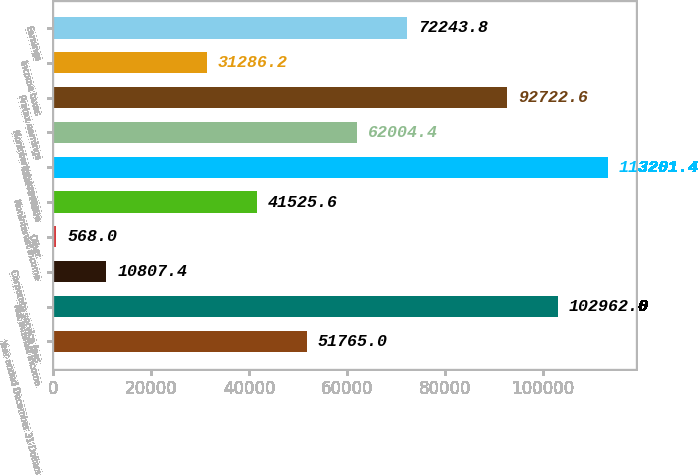Convert chart. <chart><loc_0><loc_0><loc_500><loc_500><bar_chart><fcel>Year ended December 31 Dollars<fcel>Net interest income<fcel>Corporate service fees<fcel>Other<fcel>Noninterest income<fcel>Total revenue<fcel>Noninterest expense<fcel>Pretax earnings<fcel>Income taxes<fcel>Earnings<nl><fcel>51765<fcel>102962<fcel>10807.4<fcel>568<fcel>41525.6<fcel>113201<fcel>62004.4<fcel>92722.6<fcel>31286.2<fcel>72243.8<nl></chart> 